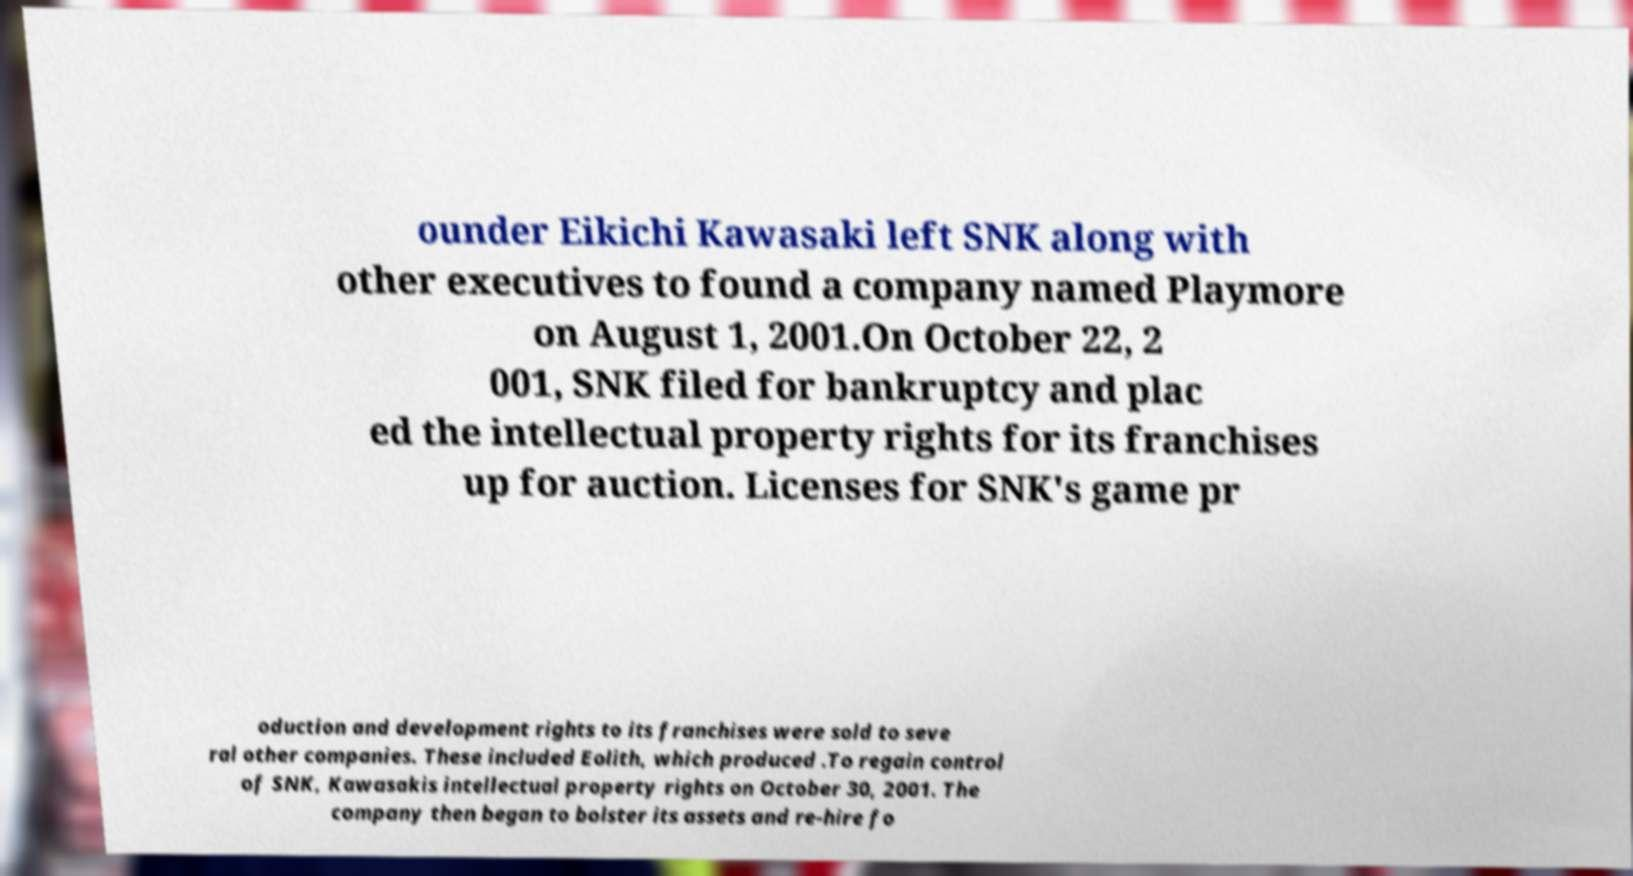For documentation purposes, I need the text within this image transcribed. Could you provide that? ounder Eikichi Kawasaki left SNK along with other executives to found a company named Playmore on August 1, 2001.On October 22, 2 001, SNK filed for bankruptcy and plac ed the intellectual property rights for its franchises up for auction. Licenses for SNK's game pr oduction and development rights to its franchises were sold to seve ral other companies. These included Eolith, which produced .To regain control of SNK, Kawasakis intellectual property rights on October 30, 2001. The company then began to bolster its assets and re-hire fo 